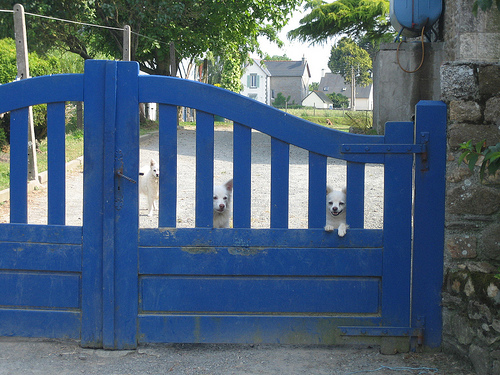<image>
Is the dog next to the fence? No. The dog is not positioned next to the fence. They are located in different areas of the scene. Is the gate behind the dogs? No. The gate is not behind the dogs. From this viewpoint, the gate appears to be positioned elsewhere in the scene. 